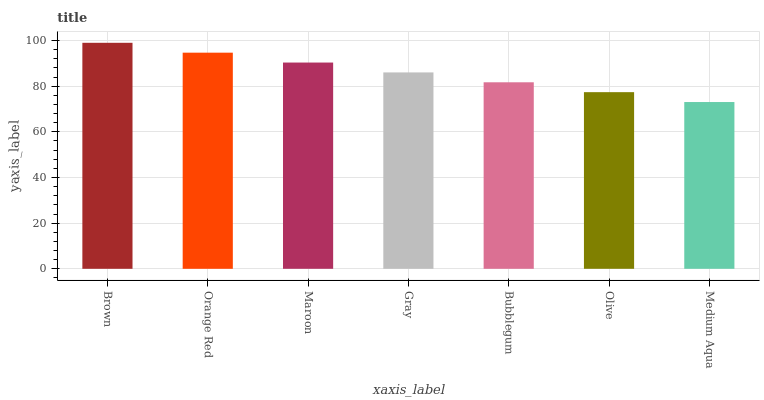Is Medium Aqua the minimum?
Answer yes or no. Yes. Is Brown the maximum?
Answer yes or no. Yes. Is Orange Red the minimum?
Answer yes or no. No. Is Orange Red the maximum?
Answer yes or no. No. Is Brown greater than Orange Red?
Answer yes or no. Yes. Is Orange Red less than Brown?
Answer yes or no. Yes. Is Orange Red greater than Brown?
Answer yes or no. No. Is Brown less than Orange Red?
Answer yes or no. No. Is Gray the high median?
Answer yes or no. Yes. Is Gray the low median?
Answer yes or no. Yes. Is Medium Aqua the high median?
Answer yes or no. No. Is Brown the low median?
Answer yes or no. No. 